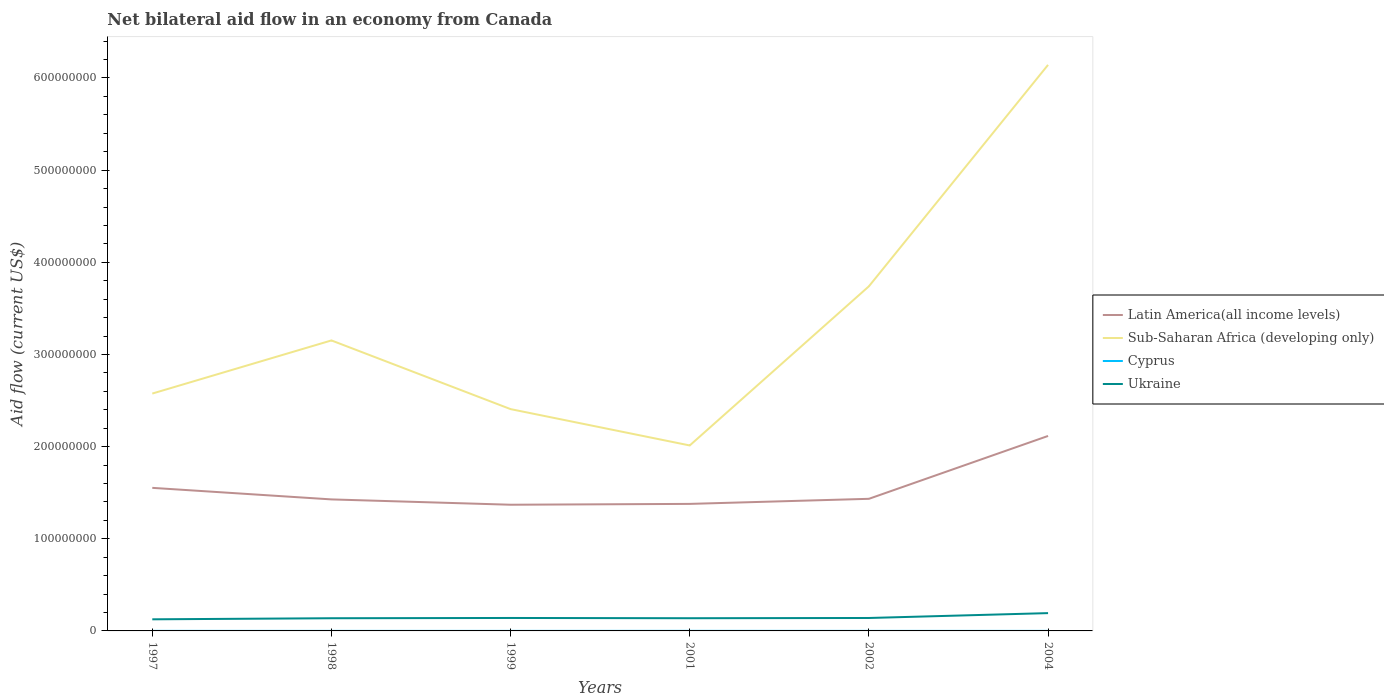How many different coloured lines are there?
Offer a very short reply. 4. Across all years, what is the maximum net bilateral aid flow in Cyprus?
Offer a very short reply. 3.00e+04. What is the total net bilateral aid flow in Sub-Saharan Africa (developing only) in the graph?
Your answer should be compact. 3.94e+07. What is the difference between the highest and the second highest net bilateral aid flow in Latin America(all income levels)?
Make the answer very short. 7.46e+07. Is the net bilateral aid flow in Cyprus strictly greater than the net bilateral aid flow in Sub-Saharan Africa (developing only) over the years?
Your response must be concise. Yes. What is the difference between two consecutive major ticks on the Y-axis?
Your answer should be compact. 1.00e+08. Does the graph contain any zero values?
Provide a short and direct response. No. How many legend labels are there?
Make the answer very short. 4. How are the legend labels stacked?
Your answer should be very brief. Vertical. What is the title of the graph?
Your answer should be compact. Net bilateral aid flow in an economy from Canada. What is the label or title of the Y-axis?
Your response must be concise. Aid flow (current US$). What is the Aid flow (current US$) in Latin America(all income levels) in 1997?
Give a very brief answer. 1.55e+08. What is the Aid flow (current US$) of Sub-Saharan Africa (developing only) in 1997?
Make the answer very short. 2.58e+08. What is the Aid flow (current US$) of Cyprus in 1997?
Give a very brief answer. 5.00e+04. What is the Aid flow (current US$) in Ukraine in 1997?
Offer a very short reply. 1.26e+07. What is the Aid flow (current US$) of Latin America(all income levels) in 1998?
Provide a short and direct response. 1.43e+08. What is the Aid flow (current US$) in Sub-Saharan Africa (developing only) in 1998?
Ensure brevity in your answer.  3.15e+08. What is the Aid flow (current US$) of Ukraine in 1998?
Your answer should be compact. 1.38e+07. What is the Aid flow (current US$) of Latin America(all income levels) in 1999?
Offer a very short reply. 1.37e+08. What is the Aid flow (current US$) in Sub-Saharan Africa (developing only) in 1999?
Provide a short and direct response. 2.41e+08. What is the Aid flow (current US$) in Cyprus in 1999?
Your answer should be compact. 3.00e+04. What is the Aid flow (current US$) in Ukraine in 1999?
Provide a short and direct response. 1.40e+07. What is the Aid flow (current US$) in Latin America(all income levels) in 2001?
Make the answer very short. 1.38e+08. What is the Aid flow (current US$) in Sub-Saharan Africa (developing only) in 2001?
Offer a terse response. 2.01e+08. What is the Aid flow (current US$) of Ukraine in 2001?
Make the answer very short. 1.38e+07. What is the Aid flow (current US$) in Latin America(all income levels) in 2002?
Keep it short and to the point. 1.43e+08. What is the Aid flow (current US$) in Sub-Saharan Africa (developing only) in 2002?
Provide a succinct answer. 3.74e+08. What is the Aid flow (current US$) in Cyprus in 2002?
Ensure brevity in your answer.  3.00e+04. What is the Aid flow (current US$) in Ukraine in 2002?
Ensure brevity in your answer.  1.40e+07. What is the Aid flow (current US$) in Latin America(all income levels) in 2004?
Offer a terse response. 2.12e+08. What is the Aid flow (current US$) of Sub-Saharan Africa (developing only) in 2004?
Provide a short and direct response. 6.14e+08. What is the Aid flow (current US$) in Cyprus in 2004?
Offer a terse response. 3.00e+04. What is the Aid flow (current US$) of Ukraine in 2004?
Give a very brief answer. 1.93e+07. Across all years, what is the maximum Aid flow (current US$) of Latin America(all income levels)?
Provide a short and direct response. 2.12e+08. Across all years, what is the maximum Aid flow (current US$) of Sub-Saharan Africa (developing only)?
Provide a short and direct response. 6.14e+08. Across all years, what is the maximum Aid flow (current US$) in Cyprus?
Keep it short and to the point. 7.00e+04. Across all years, what is the maximum Aid flow (current US$) of Ukraine?
Give a very brief answer. 1.93e+07. Across all years, what is the minimum Aid flow (current US$) of Latin America(all income levels)?
Provide a short and direct response. 1.37e+08. Across all years, what is the minimum Aid flow (current US$) of Sub-Saharan Africa (developing only)?
Offer a terse response. 2.01e+08. Across all years, what is the minimum Aid flow (current US$) of Ukraine?
Provide a succinct answer. 1.26e+07. What is the total Aid flow (current US$) in Latin America(all income levels) in the graph?
Provide a succinct answer. 9.28e+08. What is the total Aid flow (current US$) of Sub-Saharan Africa (developing only) in the graph?
Your answer should be compact. 2.00e+09. What is the total Aid flow (current US$) of Cyprus in the graph?
Keep it short and to the point. 2.40e+05. What is the total Aid flow (current US$) in Ukraine in the graph?
Provide a succinct answer. 8.76e+07. What is the difference between the Aid flow (current US$) in Latin America(all income levels) in 1997 and that in 1998?
Ensure brevity in your answer.  1.25e+07. What is the difference between the Aid flow (current US$) of Sub-Saharan Africa (developing only) in 1997 and that in 1998?
Offer a terse response. -5.76e+07. What is the difference between the Aid flow (current US$) of Ukraine in 1997 and that in 1998?
Ensure brevity in your answer.  -1.17e+06. What is the difference between the Aid flow (current US$) of Latin America(all income levels) in 1997 and that in 1999?
Give a very brief answer. 1.83e+07. What is the difference between the Aid flow (current US$) of Sub-Saharan Africa (developing only) in 1997 and that in 1999?
Your answer should be compact. 1.69e+07. What is the difference between the Aid flow (current US$) in Ukraine in 1997 and that in 1999?
Keep it short and to the point. -1.46e+06. What is the difference between the Aid flow (current US$) in Latin America(all income levels) in 1997 and that in 2001?
Your answer should be very brief. 1.74e+07. What is the difference between the Aid flow (current US$) of Sub-Saharan Africa (developing only) in 1997 and that in 2001?
Make the answer very short. 5.63e+07. What is the difference between the Aid flow (current US$) of Cyprus in 1997 and that in 2001?
Offer a terse response. -2.00e+04. What is the difference between the Aid flow (current US$) of Ukraine in 1997 and that in 2001?
Your answer should be very brief. -1.20e+06. What is the difference between the Aid flow (current US$) in Latin America(all income levels) in 1997 and that in 2002?
Ensure brevity in your answer.  1.19e+07. What is the difference between the Aid flow (current US$) in Sub-Saharan Africa (developing only) in 1997 and that in 2002?
Provide a succinct answer. -1.16e+08. What is the difference between the Aid flow (current US$) in Cyprus in 1997 and that in 2002?
Provide a short and direct response. 2.00e+04. What is the difference between the Aid flow (current US$) in Ukraine in 1997 and that in 2002?
Your answer should be very brief. -1.45e+06. What is the difference between the Aid flow (current US$) of Latin America(all income levels) in 1997 and that in 2004?
Provide a short and direct response. -5.63e+07. What is the difference between the Aid flow (current US$) in Sub-Saharan Africa (developing only) in 1997 and that in 2004?
Give a very brief answer. -3.57e+08. What is the difference between the Aid flow (current US$) of Ukraine in 1997 and that in 2004?
Give a very brief answer. -6.73e+06. What is the difference between the Aid flow (current US$) in Latin America(all income levels) in 1998 and that in 1999?
Make the answer very short. 5.78e+06. What is the difference between the Aid flow (current US$) in Sub-Saharan Africa (developing only) in 1998 and that in 1999?
Make the answer very short. 7.45e+07. What is the difference between the Aid flow (current US$) in Cyprus in 1998 and that in 1999?
Keep it short and to the point. 0. What is the difference between the Aid flow (current US$) of Latin America(all income levels) in 1998 and that in 2001?
Keep it short and to the point. 4.86e+06. What is the difference between the Aid flow (current US$) of Sub-Saharan Africa (developing only) in 1998 and that in 2001?
Your response must be concise. 1.14e+08. What is the difference between the Aid flow (current US$) of Latin America(all income levels) in 1998 and that in 2002?
Give a very brief answer. -6.40e+05. What is the difference between the Aid flow (current US$) in Sub-Saharan Africa (developing only) in 1998 and that in 2002?
Offer a terse response. -5.87e+07. What is the difference between the Aid flow (current US$) in Cyprus in 1998 and that in 2002?
Make the answer very short. 0. What is the difference between the Aid flow (current US$) of Ukraine in 1998 and that in 2002?
Make the answer very short. -2.80e+05. What is the difference between the Aid flow (current US$) of Latin America(all income levels) in 1998 and that in 2004?
Offer a very short reply. -6.89e+07. What is the difference between the Aid flow (current US$) of Sub-Saharan Africa (developing only) in 1998 and that in 2004?
Give a very brief answer. -2.99e+08. What is the difference between the Aid flow (current US$) in Cyprus in 1998 and that in 2004?
Your answer should be compact. 0. What is the difference between the Aid flow (current US$) of Ukraine in 1998 and that in 2004?
Make the answer very short. -5.56e+06. What is the difference between the Aid flow (current US$) of Latin America(all income levels) in 1999 and that in 2001?
Your response must be concise. -9.20e+05. What is the difference between the Aid flow (current US$) in Sub-Saharan Africa (developing only) in 1999 and that in 2001?
Offer a terse response. 3.94e+07. What is the difference between the Aid flow (current US$) in Cyprus in 1999 and that in 2001?
Offer a terse response. -4.00e+04. What is the difference between the Aid flow (current US$) of Latin America(all income levels) in 1999 and that in 2002?
Provide a short and direct response. -6.42e+06. What is the difference between the Aid flow (current US$) of Sub-Saharan Africa (developing only) in 1999 and that in 2002?
Keep it short and to the point. -1.33e+08. What is the difference between the Aid flow (current US$) of Ukraine in 1999 and that in 2002?
Provide a succinct answer. 10000. What is the difference between the Aid flow (current US$) of Latin America(all income levels) in 1999 and that in 2004?
Provide a succinct answer. -7.46e+07. What is the difference between the Aid flow (current US$) in Sub-Saharan Africa (developing only) in 1999 and that in 2004?
Provide a succinct answer. -3.74e+08. What is the difference between the Aid flow (current US$) in Ukraine in 1999 and that in 2004?
Keep it short and to the point. -5.27e+06. What is the difference between the Aid flow (current US$) of Latin America(all income levels) in 2001 and that in 2002?
Your response must be concise. -5.50e+06. What is the difference between the Aid flow (current US$) of Sub-Saharan Africa (developing only) in 2001 and that in 2002?
Keep it short and to the point. -1.73e+08. What is the difference between the Aid flow (current US$) in Latin America(all income levels) in 2001 and that in 2004?
Offer a terse response. -7.37e+07. What is the difference between the Aid flow (current US$) of Sub-Saharan Africa (developing only) in 2001 and that in 2004?
Provide a succinct answer. -4.13e+08. What is the difference between the Aid flow (current US$) in Cyprus in 2001 and that in 2004?
Your response must be concise. 4.00e+04. What is the difference between the Aid flow (current US$) in Ukraine in 2001 and that in 2004?
Make the answer very short. -5.53e+06. What is the difference between the Aid flow (current US$) in Latin America(all income levels) in 2002 and that in 2004?
Give a very brief answer. -6.82e+07. What is the difference between the Aid flow (current US$) of Sub-Saharan Africa (developing only) in 2002 and that in 2004?
Provide a succinct answer. -2.40e+08. What is the difference between the Aid flow (current US$) in Cyprus in 2002 and that in 2004?
Your answer should be very brief. 0. What is the difference between the Aid flow (current US$) of Ukraine in 2002 and that in 2004?
Ensure brevity in your answer.  -5.28e+06. What is the difference between the Aid flow (current US$) of Latin America(all income levels) in 1997 and the Aid flow (current US$) of Sub-Saharan Africa (developing only) in 1998?
Give a very brief answer. -1.60e+08. What is the difference between the Aid flow (current US$) in Latin America(all income levels) in 1997 and the Aid flow (current US$) in Cyprus in 1998?
Provide a short and direct response. 1.55e+08. What is the difference between the Aid flow (current US$) in Latin America(all income levels) in 1997 and the Aid flow (current US$) in Ukraine in 1998?
Offer a terse response. 1.41e+08. What is the difference between the Aid flow (current US$) in Sub-Saharan Africa (developing only) in 1997 and the Aid flow (current US$) in Cyprus in 1998?
Ensure brevity in your answer.  2.58e+08. What is the difference between the Aid flow (current US$) in Sub-Saharan Africa (developing only) in 1997 and the Aid flow (current US$) in Ukraine in 1998?
Your answer should be compact. 2.44e+08. What is the difference between the Aid flow (current US$) in Cyprus in 1997 and the Aid flow (current US$) in Ukraine in 1998?
Make the answer very short. -1.37e+07. What is the difference between the Aid flow (current US$) of Latin America(all income levels) in 1997 and the Aid flow (current US$) of Sub-Saharan Africa (developing only) in 1999?
Provide a succinct answer. -8.54e+07. What is the difference between the Aid flow (current US$) of Latin America(all income levels) in 1997 and the Aid flow (current US$) of Cyprus in 1999?
Give a very brief answer. 1.55e+08. What is the difference between the Aid flow (current US$) in Latin America(all income levels) in 1997 and the Aid flow (current US$) in Ukraine in 1999?
Ensure brevity in your answer.  1.41e+08. What is the difference between the Aid flow (current US$) of Sub-Saharan Africa (developing only) in 1997 and the Aid flow (current US$) of Cyprus in 1999?
Offer a terse response. 2.58e+08. What is the difference between the Aid flow (current US$) in Sub-Saharan Africa (developing only) in 1997 and the Aid flow (current US$) in Ukraine in 1999?
Your answer should be very brief. 2.44e+08. What is the difference between the Aid flow (current US$) in Cyprus in 1997 and the Aid flow (current US$) in Ukraine in 1999?
Offer a very short reply. -1.40e+07. What is the difference between the Aid flow (current US$) in Latin America(all income levels) in 1997 and the Aid flow (current US$) in Sub-Saharan Africa (developing only) in 2001?
Your response must be concise. -4.60e+07. What is the difference between the Aid flow (current US$) of Latin America(all income levels) in 1997 and the Aid flow (current US$) of Cyprus in 2001?
Keep it short and to the point. 1.55e+08. What is the difference between the Aid flow (current US$) of Latin America(all income levels) in 1997 and the Aid flow (current US$) of Ukraine in 2001?
Provide a succinct answer. 1.41e+08. What is the difference between the Aid flow (current US$) in Sub-Saharan Africa (developing only) in 1997 and the Aid flow (current US$) in Cyprus in 2001?
Your response must be concise. 2.58e+08. What is the difference between the Aid flow (current US$) of Sub-Saharan Africa (developing only) in 1997 and the Aid flow (current US$) of Ukraine in 2001?
Make the answer very short. 2.44e+08. What is the difference between the Aid flow (current US$) of Cyprus in 1997 and the Aid flow (current US$) of Ukraine in 2001?
Keep it short and to the point. -1.37e+07. What is the difference between the Aid flow (current US$) in Latin America(all income levels) in 1997 and the Aid flow (current US$) in Sub-Saharan Africa (developing only) in 2002?
Ensure brevity in your answer.  -2.19e+08. What is the difference between the Aid flow (current US$) in Latin America(all income levels) in 1997 and the Aid flow (current US$) in Cyprus in 2002?
Keep it short and to the point. 1.55e+08. What is the difference between the Aid flow (current US$) in Latin America(all income levels) in 1997 and the Aid flow (current US$) in Ukraine in 2002?
Your response must be concise. 1.41e+08. What is the difference between the Aid flow (current US$) of Sub-Saharan Africa (developing only) in 1997 and the Aid flow (current US$) of Cyprus in 2002?
Provide a short and direct response. 2.58e+08. What is the difference between the Aid flow (current US$) of Sub-Saharan Africa (developing only) in 1997 and the Aid flow (current US$) of Ukraine in 2002?
Your response must be concise. 2.44e+08. What is the difference between the Aid flow (current US$) of Cyprus in 1997 and the Aid flow (current US$) of Ukraine in 2002?
Offer a very short reply. -1.40e+07. What is the difference between the Aid flow (current US$) in Latin America(all income levels) in 1997 and the Aid flow (current US$) in Sub-Saharan Africa (developing only) in 2004?
Your answer should be very brief. -4.59e+08. What is the difference between the Aid flow (current US$) in Latin America(all income levels) in 1997 and the Aid flow (current US$) in Cyprus in 2004?
Provide a short and direct response. 1.55e+08. What is the difference between the Aid flow (current US$) of Latin America(all income levels) in 1997 and the Aid flow (current US$) of Ukraine in 2004?
Provide a short and direct response. 1.36e+08. What is the difference between the Aid flow (current US$) in Sub-Saharan Africa (developing only) in 1997 and the Aid flow (current US$) in Cyprus in 2004?
Give a very brief answer. 2.58e+08. What is the difference between the Aid flow (current US$) of Sub-Saharan Africa (developing only) in 1997 and the Aid flow (current US$) of Ukraine in 2004?
Provide a succinct answer. 2.38e+08. What is the difference between the Aid flow (current US$) of Cyprus in 1997 and the Aid flow (current US$) of Ukraine in 2004?
Offer a terse response. -1.93e+07. What is the difference between the Aid flow (current US$) of Latin America(all income levels) in 1998 and the Aid flow (current US$) of Sub-Saharan Africa (developing only) in 1999?
Offer a terse response. -9.80e+07. What is the difference between the Aid flow (current US$) of Latin America(all income levels) in 1998 and the Aid flow (current US$) of Cyprus in 1999?
Your answer should be very brief. 1.43e+08. What is the difference between the Aid flow (current US$) of Latin America(all income levels) in 1998 and the Aid flow (current US$) of Ukraine in 1999?
Provide a short and direct response. 1.29e+08. What is the difference between the Aid flow (current US$) of Sub-Saharan Africa (developing only) in 1998 and the Aid flow (current US$) of Cyprus in 1999?
Ensure brevity in your answer.  3.15e+08. What is the difference between the Aid flow (current US$) in Sub-Saharan Africa (developing only) in 1998 and the Aid flow (current US$) in Ukraine in 1999?
Offer a very short reply. 3.01e+08. What is the difference between the Aid flow (current US$) of Cyprus in 1998 and the Aid flow (current US$) of Ukraine in 1999?
Make the answer very short. -1.40e+07. What is the difference between the Aid flow (current US$) of Latin America(all income levels) in 1998 and the Aid flow (current US$) of Sub-Saharan Africa (developing only) in 2001?
Your answer should be very brief. -5.86e+07. What is the difference between the Aid flow (current US$) in Latin America(all income levels) in 1998 and the Aid flow (current US$) in Cyprus in 2001?
Your response must be concise. 1.43e+08. What is the difference between the Aid flow (current US$) of Latin America(all income levels) in 1998 and the Aid flow (current US$) of Ukraine in 2001?
Make the answer very short. 1.29e+08. What is the difference between the Aid flow (current US$) in Sub-Saharan Africa (developing only) in 1998 and the Aid flow (current US$) in Cyprus in 2001?
Your answer should be compact. 3.15e+08. What is the difference between the Aid flow (current US$) of Sub-Saharan Africa (developing only) in 1998 and the Aid flow (current US$) of Ukraine in 2001?
Your answer should be compact. 3.01e+08. What is the difference between the Aid flow (current US$) of Cyprus in 1998 and the Aid flow (current US$) of Ukraine in 2001?
Your response must be concise. -1.38e+07. What is the difference between the Aid flow (current US$) of Latin America(all income levels) in 1998 and the Aid flow (current US$) of Sub-Saharan Africa (developing only) in 2002?
Your answer should be compact. -2.31e+08. What is the difference between the Aid flow (current US$) in Latin America(all income levels) in 1998 and the Aid flow (current US$) in Cyprus in 2002?
Keep it short and to the point. 1.43e+08. What is the difference between the Aid flow (current US$) of Latin America(all income levels) in 1998 and the Aid flow (current US$) of Ukraine in 2002?
Your response must be concise. 1.29e+08. What is the difference between the Aid flow (current US$) of Sub-Saharan Africa (developing only) in 1998 and the Aid flow (current US$) of Cyprus in 2002?
Offer a very short reply. 3.15e+08. What is the difference between the Aid flow (current US$) in Sub-Saharan Africa (developing only) in 1998 and the Aid flow (current US$) in Ukraine in 2002?
Your answer should be compact. 3.01e+08. What is the difference between the Aid flow (current US$) in Cyprus in 1998 and the Aid flow (current US$) in Ukraine in 2002?
Provide a short and direct response. -1.40e+07. What is the difference between the Aid flow (current US$) of Latin America(all income levels) in 1998 and the Aid flow (current US$) of Sub-Saharan Africa (developing only) in 2004?
Offer a very short reply. -4.72e+08. What is the difference between the Aid flow (current US$) of Latin America(all income levels) in 1998 and the Aid flow (current US$) of Cyprus in 2004?
Offer a very short reply. 1.43e+08. What is the difference between the Aid flow (current US$) of Latin America(all income levels) in 1998 and the Aid flow (current US$) of Ukraine in 2004?
Provide a short and direct response. 1.23e+08. What is the difference between the Aid flow (current US$) of Sub-Saharan Africa (developing only) in 1998 and the Aid flow (current US$) of Cyprus in 2004?
Make the answer very short. 3.15e+08. What is the difference between the Aid flow (current US$) of Sub-Saharan Africa (developing only) in 1998 and the Aid flow (current US$) of Ukraine in 2004?
Provide a short and direct response. 2.96e+08. What is the difference between the Aid flow (current US$) of Cyprus in 1998 and the Aid flow (current US$) of Ukraine in 2004?
Give a very brief answer. -1.93e+07. What is the difference between the Aid flow (current US$) in Latin America(all income levels) in 1999 and the Aid flow (current US$) in Sub-Saharan Africa (developing only) in 2001?
Offer a terse response. -6.43e+07. What is the difference between the Aid flow (current US$) in Latin America(all income levels) in 1999 and the Aid flow (current US$) in Cyprus in 2001?
Offer a terse response. 1.37e+08. What is the difference between the Aid flow (current US$) in Latin America(all income levels) in 1999 and the Aid flow (current US$) in Ukraine in 2001?
Provide a short and direct response. 1.23e+08. What is the difference between the Aid flow (current US$) of Sub-Saharan Africa (developing only) in 1999 and the Aid flow (current US$) of Cyprus in 2001?
Keep it short and to the point. 2.41e+08. What is the difference between the Aid flow (current US$) of Sub-Saharan Africa (developing only) in 1999 and the Aid flow (current US$) of Ukraine in 2001?
Give a very brief answer. 2.27e+08. What is the difference between the Aid flow (current US$) in Cyprus in 1999 and the Aid flow (current US$) in Ukraine in 2001?
Give a very brief answer. -1.38e+07. What is the difference between the Aid flow (current US$) of Latin America(all income levels) in 1999 and the Aid flow (current US$) of Sub-Saharan Africa (developing only) in 2002?
Your answer should be very brief. -2.37e+08. What is the difference between the Aid flow (current US$) in Latin America(all income levels) in 1999 and the Aid flow (current US$) in Cyprus in 2002?
Provide a short and direct response. 1.37e+08. What is the difference between the Aid flow (current US$) of Latin America(all income levels) in 1999 and the Aid flow (current US$) of Ukraine in 2002?
Provide a succinct answer. 1.23e+08. What is the difference between the Aid flow (current US$) of Sub-Saharan Africa (developing only) in 1999 and the Aid flow (current US$) of Cyprus in 2002?
Provide a succinct answer. 2.41e+08. What is the difference between the Aid flow (current US$) in Sub-Saharan Africa (developing only) in 1999 and the Aid flow (current US$) in Ukraine in 2002?
Provide a short and direct response. 2.27e+08. What is the difference between the Aid flow (current US$) of Cyprus in 1999 and the Aid flow (current US$) of Ukraine in 2002?
Offer a terse response. -1.40e+07. What is the difference between the Aid flow (current US$) in Latin America(all income levels) in 1999 and the Aid flow (current US$) in Sub-Saharan Africa (developing only) in 2004?
Provide a short and direct response. -4.77e+08. What is the difference between the Aid flow (current US$) of Latin America(all income levels) in 1999 and the Aid flow (current US$) of Cyprus in 2004?
Offer a very short reply. 1.37e+08. What is the difference between the Aid flow (current US$) of Latin America(all income levels) in 1999 and the Aid flow (current US$) of Ukraine in 2004?
Offer a terse response. 1.18e+08. What is the difference between the Aid flow (current US$) in Sub-Saharan Africa (developing only) in 1999 and the Aid flow (current US$) in Cyprus in 2004?
Give a very brief answer. 2.41e+08. What is the difference between the Aid flow (current US$) of Sub-Saharan Africa (developing only) in 1999 and the Aid flow (current US$) of Ukraine in 2004?
Offer a very short reply. 2.21e+08. What is the difference between the Aid flow (current US$) of Cyprus in 1999 and the Aid flow (current US$) of Ukraine in 2004?
Ensure brevity in your answer.  -1.93e+07. What is the difference between the Aid flow (current US$) of Latin America(all income levels) in 2001 and the Aid flow (current US$) of Sub-Saharan Africa (developing only) in 2002?
Provide a short and direct response. -2.36e+08. What is the difference between the Aid flow (current US$) in Latin America(all income levels) in 2001 and the Aid flow (current US$) in Cyprus in 2002?
Your response must be concise. 1.38e+08. What is the difference between the Aid flow (current US$) of Latin America(all income levels) in 2001 and the Aid flow (current US$) of Ukraine in 2002?
Provide a succinct answer. 1.24e+08. What is the difference between the Aid flow (current US$) of Sub-Saharan Africa (developing only) in 2001 and the Aid flow (current US$) of Cyprus in 2002?
Your answer should be compact. 2.01e+08. What is the difference between the Aid flow (current US$) in Sub-Saharan Africa (developing only) in 2001 and the Aid flow (current US$) in Ukraine in 2002?
Ensure brevity in your answer.  1.87e+08. What is the difference between the Aid flow (current US$) in Cyprus in 2001 and the Aid flow (current US$) in Ukraine in 2002?
Provide a succinct answer. -1.40e+07. What is the difference between the Aid flow (current US$) in Latin America(all income levels) in 2001 and the Aid flow (current US$) in Sub-Saharan Africa (developing only) in 2004?
Make the answer very short. -4.76e+08. What is the difference between the Aid flow (current US$) in Latin America(all income levels) in 2001 and the Aid flow (current US$) in Cyprus in 2004?
Your answer should be compact. 1.38e+08. What is the difference between the Aid flow (current US$) in Latin America(all income levels) in 2001 and the Aid flow (current US$) in Ukraine in 2004?
Your response must be concise. 1.19e+08. What is the difference between the Aid flow (current US$) of Sub-Saharan Africa (developing only) in 2001 and the Aid flow (current US$) of Cyprus in 2004?
Offer a terse response. 2.01e+08. What is the difference between the Aid flow (current US$) of Sub-Saharan Africa (developing only) in 2001 and the Aid flow (current US$) of Ukraine in 2004?
Provide a succinct answer. 1.82e+08. What is the difference between the Aid flow (current US$) in Cyprus in 2001 and the Aid flow (current US$) in Ukraine in 2004?
Your response must be concise. -1.92e+07. What is the difference between the Aid flow (current US$) in Latin America(all income levels) in 2002 and the Aid flow (current US$) in Sub-Saharan Africa (developing only) in 2004?
Your answer should be compact. -4.71e+08. What is the difference between the Aid flow (current US$) of Latin America(all income levels) in 2002 and the Aid flow (current US$) of Cyprus in 2004?
Offer a terse response. 1.43e+08. What is the difference between the Aid flow (current US$) of Latin America(all income levels) in 2002 and the Aid flow (current US$) of Ukraine in 2004?
Provide a succinct answer. 1.24e+08. What is the difference between the Aid flow (current US$) of Sub-Saharan Africa (developing only) in 2002 and the Aid flow (current US$) of Cyprus in 2004?
Your answer should be compact. 3.74e+08. What is the difference between the Aid flow (current US$) of Sub-Saharan Africa (developing only) in 2002 and the Aid flow (current US$) of Ukraine in 2004?
Give a very brief answer. 3.55e+08. What is the difference between the Aid flow (current US$) in Cyprus in 2002 and the Aid flow (current US$) in Ukraine in 2004?
Ensure brevity in your answer.  -1.93e+07. What is the average Aid flow (current US$) of Latin America(all income levels) per year?
Your answer should be very brief. 1.55e+08. What is the average Aid flow (current US$) in Sub-Saharan Africa (developing only) per year?
Provide a succinct answer. 3.34e+08. What is the average Aid flow (current US$) in Cyprus per year?
Your answer should be very brief. 4.00e+04. What is the average Aid flow (current US$) of Ukraine per year?
Ensure brevity in your answer.  1.46e+07. In the year 1997, what is the difference between the Aid flow (current US$) of Latin America(all income levels) and Aid flow (current US$) of Sub-Saharan Africa (developing only)?
Your answer should be very brief. -1.02e+08. In the year 1997, what is the difference between the Aid flow (current US$) of Latin America(all income levels) and Aid flow (current US$) of Cyprus?
Make the answer very short. 1.55e+08. In the year 1997, what is the difference between the Aid flow (current US$) in Latin America(all income levels) and Aid flow (current US$) in Ukraine?
Offer a very short reply. 1.43e+08. In the year 1997, what is the difference between the Aid flow (current US$) of Sub-Saharan Africa (developing only) and Aid flow (current US$) of Cyprus?
Give a very brief answer. 2.58e+08. In the year 1997, what is the difference between the Aid flow (current US$) of Sub-Saharan Africa (developing only) and Aid flow (current US$) of Ukraine?
Ensure brevity in your answer.  2.45e+08. In the year 1997, what is the difference between the Aid flow (current US$) in Cyprus and Aid flow (current US$) in Ukraine?
Keep it short and to the point. -1.25e+07. In the year 1998, what is the difference between the Aid flow (current US$) in Latin America(all income levels) and Aid flow (current US$) in Sub-Saharan Africa (developing only)?
Provide a short and direct response. -1.73e+08. In the year 1998, what is the difference between the Aid flow (current US$) in Latin America(all income levels) and Aid flow (current US$) in Cyprus?
Your response must be concise. 1.43e+08. In the year 1998, what is the difference between the Aid flow (current US$) in Latin America(all income levels) and Aid flow (current US$) in Ukraine?
Offer a very short reply. 1.29e+08. In the year 1998, what is the difference between the Aid flow (current US$) in Sub-Saharan Africa (developing only) and Aid flow (current US$) in Cyprus?
Your answer should be compact. 3.15e+08. In the year 1998, what is the difference between the Aid flow (current US$) in Sub-Saharan Africa (developing only) and Aid flow (current US$) in Ukraine?
Your answer should be very brief. 3.01e+08. In the year 1998, what is the difference between the Aid flow (current US$) of Cyprus and Aid flow (current US$) of Ukraine?
Your answer should be very brief. -1.37e+07. In the year 1999, what is the difference between the Aid flow (current US$) in Latin America(all income levels) and Aid flow (current US$) in Sub-Saharan Africa (developing only)?
Your response must be concise. -1.04e+08. In the year 1999, what is the difference between the Aid flow (current US$) in Latin America(all income levels) and Aid flow (current US$) in Cyprus?
Provide a succinct answer. 1.37e+08. In the year 1999, what is the difference between the Aid flow (current US$) of Latin America(all income levels) and Aid flow (current US$) of Ukraine?
Provide a short and direct response. 1.23e+08. In the year 1999, what is the difference between the Aid flow (current US$) in Sub-Saharan Africa (developing only) and Aid flow (current US$) in Cyprus?
Keep it short and to the point. 2.41e+08. In the year 1999, what is the difference between the Aid flow (current US$) in Sub-Saharan Africa (developing only) and Aid flow (current US$) in Ukraine?
Make the answer very short. 2.27e+08. In the year 1999, what is the difference between the Aid flow (current US$) in Cyprus and Aid flow (current US$) in Ukraine?
Make the answer very short. -1.40e+07. In the year 2001, what is the difference between the Aid flow (current US$) in Latin America(all income levels) and Aid flow (current US$) in Sub-Saharan Africa (developing only)?
Ensure brevity in your answer.  -6.34e+07. In the year 2001, what is the difference between the Aid flow (current US$) of Latin America(all income levels) and Aid flow (current US$) of Cyprus?
Your answer should be compact. 1.38e+08. In the year 2001, what is the difference between the Aid flow (current US$) in Latin America(all income levels) and Aid flow (current US$) in Ukraine?
Offer a very short reply. 1.24e+08. In the year 2001, what is the difference between the Aid flow (current US$) of Sub-Saharan Africa (developing only) and Aid flow (current US$) of Cyprus?
Keep it short and to the point. 2.01e+08. In the year 2001, what is the difference between the Aid flow (current US$) of Sub-Saharan Africa (developing only) and Aid flow (current US$) of Ukraine?
Provide a succinct answer. 1.87e+08. In the year 2001, what is the difference between the Aid flow (current US$) of Cyprus and Aid flow (current US$) of Ukraine?
Provide a succinct answer. -1.37e+07. In the year 2002, what is the difference between the Aid flow (current US$) of Latin America(all income levels) and Aid flow (current US$) of Sub-Saharan Africa (developing only)?
Provide a short and direct response. -2.31e+08. In the year 2002, what is the difference between the Aid flow (current US$) in Latin America(all income levels) and Aid flow (current US$) in Cyprus?
Make the answer very short. 1.43e+08. In the year 2002, what is the difference between the Aid flow (current US$) in Latin America(all income levels) and Aid flow (current US$) in Ukraine?
Your response must be concise. 1.29e+08. In the year 2002, what is the difference between the Aid flow (current US$) in Sub-Saharan Africa (developing only) and Aid flow (current US$) in Cyprus?
Offer a very short reply. 3.74e+08. In the year 2002, what is the difference between the Aid flow (current US$) in Sub-Saharan Africa (developing only) and Aid flow (current US$) in Ukraine?
Your answer should be compact. 3.60e+08. In the year 2002, what is the difference between the Aid flow (current US$) of Cyprus and Aid flow (current US$) of Ukraine?
Give a very brief answer. -1.40e+07. In the year 2004, what is the difference between the Aid flow (current US$) in Latin America(all income levels) and Aid flow (current US$) in Sub-Saharan Africa (developing only)?
Your response must be concise. -4.03e+08. In the year 2004, what is the difference between the Aid flow (current US$) of Latin America(all income levels) and Aid flow (current US$) of Cyprus?
Your answer should be compact. 2.12e+08. In the year 2004, what is the difference between the Aid flow (current US$) in Latin America(all income levels) and Aid flow (current US$) in Ukraine?
Provide a short and direct response. 1.92e+08. In the year 2004, what is the difference between the Aid flow (current US$) in Sub-Saharan Africa (developing only) and Aid flow (current US$) in Cyprus?
Offer a very short reply. 6.14e+08. In the year 2004, what is the difference between the Aid flow (current US$) in Sub-Saharan Africa (developing only) and Aid flow (current US$) in Ukraine?
Provide a short and direct response. 5.95e+08. In the year 2004, what is the difference between the Aid flow (current US$) of Cyprus and Aid flow (current US$) of Ukraine?
Provide a short and direct response. -1.93e+07. What is the ratio of the Aid flow (current US$) in Latin America(all income levels) in 1997 to that in 1998?
Keep it short and to the point. 1.09. What is the ratio of the Aid flow (current US$) in Sub-Saharan Africa (developing only) in 1997 to that in 1998?
Keep it short and to the point. 0.82. What is the ratio of the Aid flow (current US$) of Cyprus in 1997 to that in 1998?
Provide a short and direct response. 1.67. What is the ratio of the Aid flow (current US$) of Ukraine in 1997 to that in 1998?
Offer a terse response. 0.92. What is the ratio of the Aid flow (current US$) of Latin America(all income levels) in 1997 to that in 1999?
Make the answer very short. 1.13. What is the ratio of the Aid flow (current US$) of Sub-Saharan Africa (developing only) in 1997 to that in 1999?
Provide a succinct answer. 1.07. What is the ratio of the Aid flow (current US$) of Ukraine in 1997 to that in 1999?
Your response must be concise. 0.9. What is the ratio of the Aid flow (current US$) in Latin America(all income levels) in 1997 to that in 2001?
Offer a terse response. 1.13. What is the ratio of the Aid flow (current US$) in Sub-Saharan Africa (developing only) in 1997 to that in 2001?
Your response must be concise. 1.28. What is the ratio of the Aid flow (current US$) of Cyprus in 1997 to that in 2001?
Your answer should be compact. 0.71. What is the ratio of the Aid flow (current US$) in Ukraine in 1997 to that in 2001?
Your answer should be very brief. 0.91. What is the ratio of the Aid flow (current US$) in Latin America(all income levels) in 1997 to that in 2002?
Keep it short and to the point. 1.08. What is the ratio of the Aid flow (current US$) in Sub-Saharan Africa (developing only) in 1997 to that in 2002?
Offer a very short reply. 0.69. What is the ratio of the Aid flow (current US$) of Cyprus in 1997 to that in 2002?
Provide a succinct answer. 1.67. What is the ratio of the Aid flow (current US$) in Ukraine in 1997 to that in 2002?
Make the answer very short. 0.9. What is the ratio of the Aid flow (current US$) of Latin America(all income levels) in 1997 to that in 2004?
Your response must be concise. 0.73. What is the ratio of the Aid flow (current US$) of Sub-Saharan Africa (developing only) in 1997 to that in 2004?
Your response must be concise. 0.42. What is the ratio of the Aid flow (current US$) in Ukraine in 1997 to that in 2004?
Your answer should be compact. 0.65. What is the ratio of the Aid flow (current US$) in Latin America(all income levels) in 1998 to that in 1999?
Make the answer very short. 1.04. What is the ratio of the Aid flow (current US$) in Sub-Saharan Africa (developing only) in 1998 to that in 1999?
Offer a terse response. 1.31. What is the ratio of the Aid flow (current US$) of Cyprus in 1998 to that in 1999?
Keep it short and to the point. 1. What is the ratio of the Aid flow (current US$) of Ukraine in 1998 to that in 1999?
Provide a succinct answer. 0.98. What is the ratio of the Aid flow (current US$) in Latin America(all income levels) in 1998 to that in 2001?
Offer a terse response. 1.04. What is the ratio of the Aid flow (current US$) in Sub-Saharan Africa (developing only) in 1998 to that in 2001?
Your answer should be compact. 1.57. What is the ratio of the Aid flow (current US$) of Cyprus in 1998 to that in 2001?
Offer a terse response. 0.43. What is the ratio of the Aid flow (current US$) of Ukraine in 1998 to that in 2001?
Offer a very short reply. 1. What is the ratio of the Aid flow (current US$) in Sub-Saharan Africa (developing only) in 1998 to that in 2002?
Provide a short and direct response. 0.84. What is the ratio of the Aid flow (current US$) of Ukraine in 1998 to that in 2002?
Provide a succinct answer. 0.98. What is the ratio of the Aid flow (current US$) of Latin America(all income levels) in 1998 to that in 2004?
Offer a terse response. 0.67. What is the ratio of the Aid flow (current US$) of Sub-Saharan Africa (developing only) in 1998 to that in 2004?
Your response must be concise. 0.51. What is the ratio of the Aid flow (current US$) of Ukraine in 1998 to that in 2004?
Provide a succinct answer. 0.71. What is the ratio of the Aid flow (current US$) in Latin America(all income levels) in 1999 to that in 2001?
Offer a very short reply. 0.99. What is the ratio of the Aid flow (current US$) in Sub-Saharan Africa (developing only) in 1999 to that in 2001?
Keep it short and to the point. 1.2. What is the ratio of the Aid flow (current US$) of Cyprus in 1999 to that in 2001?
Your answer should be compact. 0.43. What is the ratio of the Aid flow (current US$) in Ukraine in 1999 to that in 2001?
Make the answer very short. 1.02. What is the ratio of the Aid flow (current US$) in Latin America(all income levels) in 1999 to that in 2002?
Make the answer very short. 0.96. What is the ratio of the Aid flow (current US$) of Sub-Saharan Africa (developing only) in 1999 to that in 2002?
Offer a very short reply. 0.64. What is the ratio of the Aid flow (current US$) in Cyprus in 1999 to that in 2002?
Your answer should be compact. 1. What is the ratio of the Aid flow (current US$) of Ukraine in 1999 to that in 2002?
Make the answer very short. 1. What is the ratio of the Aid flow (current US$) in Latin America(all income levels) in 1999 to that in 2004?
Keep it short and to the point. 0.65. What is the ratio of the Aid flow (current US$) in Sub-Saharan Africa (developing only) in 1999 to that in 2004?
Your answer should be very brief. 0.39. What is the ratio of the Aid flow (current US$) of Cyprus in 1999 to that in 2004?
Offer a terse response. 1. What is the ratio of the Aid flow (current US$) in Ukraine in 1999 to that in 2004?
Provide a short and direct response. 0.73. What is the ratio of the Aid flow (current US$) of Latin America(all income levels) in 2001 to that in 2002?
Provide a succinct answer. 0.96. What is the ratio of the Aid flow (current US$) of Sub-Saharan Africa (developing only) in 2001 to that in 2002?
Your response must be concise. 0.54. What is the ratio of the Aid flow (current US$) of Cyprus in 2001 to that in 2002?
Your answer should be compact. 2.33. What is the ratio of the Aid flow (current US$) in Ukraine in 2001 to that in 2002?
Ensure brevity in your answer.  0.98. What is the ratio of the Aid flow (current US$) in Latin America(all income levels) in 2001 to that in 2004?
Provide a succinct answer. 0.65. What is the ratio of the Aid flow (current US$) in Sub-Saharan Africa (developing only) in 2001 to that in 2004?
Offer a very short reply. 0.33. What is the ratio of the Aid flow (current US$) of Cyprus in 2001 to that in 2004?
Provide a short and direct response. 2.33. What is the ratio of the Aid flow (current US$) of Ukraine in 2001 to that in 2004?
Give a very brief answer. 0.71. What is the ratio of the Aid flow (current US$) of Latin America(all income levels) in 2002 to that in 2004?
Keep it short and to the point. 0.68. What is the ratio of the Aid flow (current US$) of Sub-Saharan Africa (developing only) in 2002 to that in 2004?
Make the answer very short. 0.61. What is the ratio of the Aid flow (current US$) in Cyprus in 2002 to that in 2004?
Ensure brevity in your answer.  1. What is the ratio of the Aid flow (current US$) of Ukraine in 2002 to that in 2004?
Your answer should be very brief. 0.73. What is the difference between the highest and the second highest Aid flow (current US$) in Latin America(all income levels)?
Your response must be concise. 5.63e+07. What is the difference between the highest and the second highest Aid flow (current US$) of Sub-Saharan Africa (developing only)?
Your answer should be very brief. 2.40e+08. What is the difference between the highest and the second highest Aid flow (current US$) of Cyprus?
Provide a short and direct response. 2.00e+04. What is the difference between the highest and the second highest Aid flow (current US$) in Ukraine?
Make the answer very short. 5.27e+06. What is the difference between the highest and the lowest Aid flow (current US$) of Latin America(all income levels)?
Keep it short and to the point. 7.46e+07. What is the difference between the highest and the lowest Aid flow (current US$) of Sub-Saharan Africa (developing only)?
Your answer should be compact. 4.13e+08. What is the difference between the highest and the lowest Aid flow (current US$) in Cyprus?
Your answer should be compact. 4.00e+04. What is the difference between the highest and the lowest Aid flow (current US$) of Ukraine?
Give a very brief answer. 6.73e+06. 